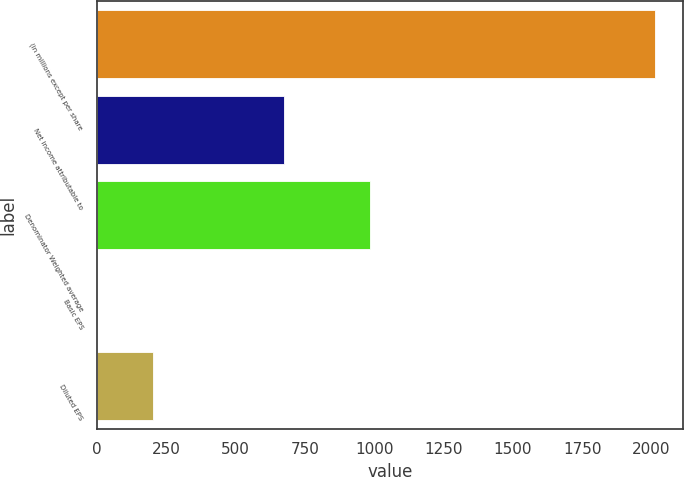<chart> <loc_0><loc_0><loc_500><loc_500><bar_chart><fcel>(in millions except per share<fcel>Net income attributable to<fcel>Denominator Weighted average<fcel>Basic EPS<fcel>Diluted EPS<nl><fcel>2014<fcel>673<fcel>985<fcel>0.68<fcel>202.01<nl></chart> 